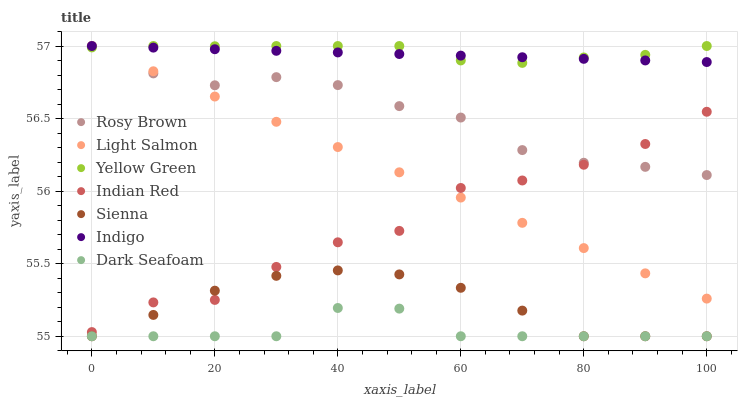Does Dark Seafoam have the minimum area under the curve?
Answer yes or no. Yes. Does Yellow Green have the maximum area under the curve?
Answer yes or no. Yes. Does Indigo have the minimum area under the curve?
Answer yes or no. No. Does Indigo have the maximum area under the curve?
Answer yes or no. No. Is Indigo the smoothest?
Answer yes or no. Yes. Is Indian Red the roughest?
Answer yes or no. Yes. Is Yellow Green the smoothest?
Answer yes or no. No. Is Yellow Green the roughest?
Answer yes or no. No. Does Sienna have the lowest value?
Answer yes or no. Yes. Does Yellow Green have the lowest value?
Answer yes or no. No. Does Rosy Brown have the highest value?
Answer yes or no. Yes. Does Sienna have the highest value?
Answer yes or no. No. Is Indian Red less than Yellow Green?
Answer yes or no. Yes. Is Light Salmon greater than Dark Seafoam?
Answer yes or no. Yes. Does Sienna intersect Dark Seafoam?
Answer yes or no. Yes. Is Sienna less than Dark Seafoam?
Answer yes or no. No. Is Sienna greater than Dark Seafoam?
Answer yes or no. No. Does Indian Red intersect Yellow Green?
Answer yes or no. No. 